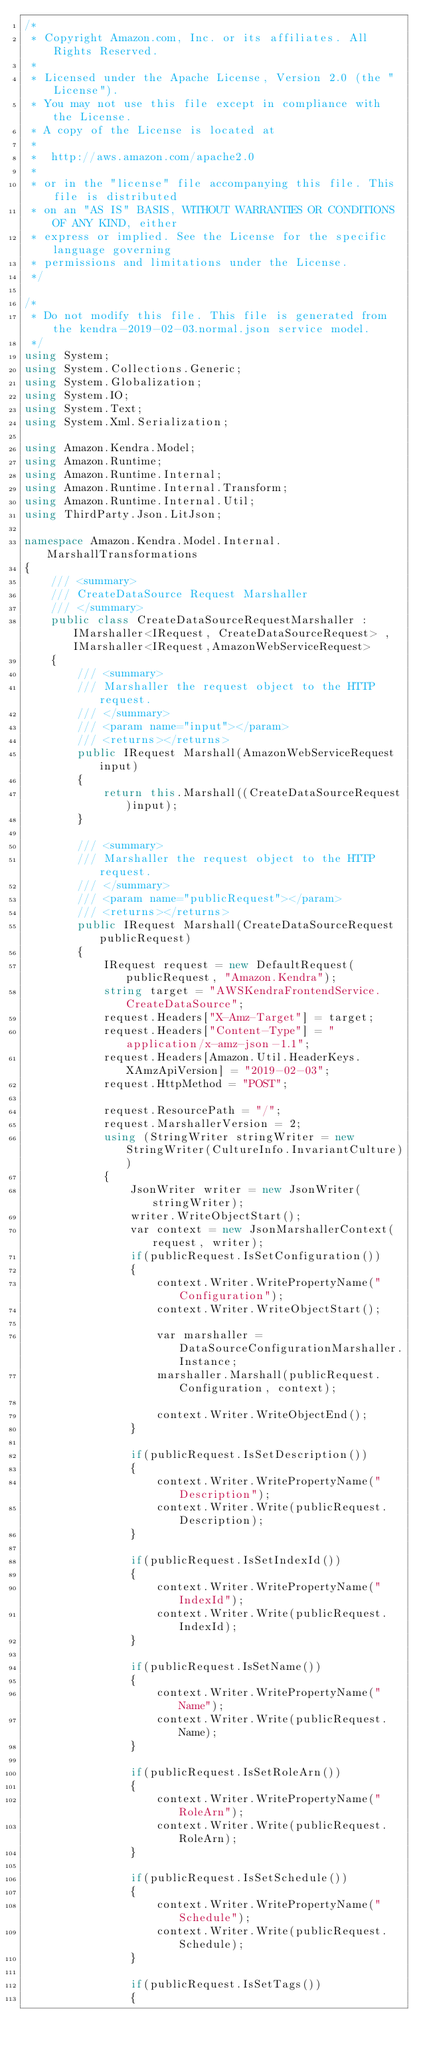Convert code to text. <code><loc_0><loc_0><loc_500><loc_500><_C#_>/*
 * Copyright Amazon.com, Inc. or its affiliates. All Rights Reserved.
 * 
 * Licensed under the Apache License, Version 2.0 (the "License").
 * You may not use this file except in compliance with the License.
 * A copy of the License is located at
 * 
 *  http://aws.amazon.com/apache2.0
 * 
 * or in the "license" file accompanying this file. This file is distributed
 * on an "AS IS" BASIS, WITHOUT WARRANTIES OR CONDITIONS OF ANY KIND, either
 * express or implied. See the License for the specific language governing
 * permissions and limitations under the License.
 */

/*
 * Do not modify this file. This file is generated from the kendra-2019-02-03.normal.json service model.
 */
using System;
using System.Collections.Generic;
using System.Globalization;
using System.IO;
using System.Text;
using System.Xml.Serialization;

using Amazon.Kendra.Model;
using Amazon.Runtime;
using Amazon.Runtime.Internal;
using Amazon.Runtime.Internal.Transform;
using Amazon.Runtime.Internal.Util;
using ThirdParty.Json.LitJson;

namespace Amazon.Kendra.Model.Internal.MarshallTransformations
{
    /// <summary>
    /// CreateDataSource Request Marshaller
    /// </summary>       
    public class CreateDataSourceRequestMarshaller : IMarshaller<IRequest, CreateDataSourceRequest> , IMarshaller<IRequest,AmazonWebServiceRequest>
    {
        /// <summary>
        /// Marshaller the request object to the HTTP request.
        /// </summary>  
        /// <param name="input"></param>
        /// <returns></returns>
        public IRequest Marshall(AmazonWebServiceRequest input)
        {
            return this.Marshall((CreateDataSourceRequest)input);
        }

        /// <summary>
        /// Marshaller the request object to the HTTP request.
        /// </summary>  
        /// <param name="publicRequest"></param>
        /// <returns></returns>
        public IRequest Marshall(CreateDataSourceRequest publicRequest)
        {
            IRequest request = new DefaultRequest(publicRequest, "Amazon.Kendra");
            string target = "AWSKendraFrontendService.CreateDataSource";
            request.Headers["X-Amz-Target"] = target;
            request.Headers["Content-Type"] = "application/x-amz-json-1.1";
            request.Headers[Amazon.Util.HeaderKeys.XAmzApiVersion] = "2019-02-03";            
            request.HttpMethod = "POST";

            request.ResourcePath = "/";
            request.MarshallerVersion = 2;
            using (StringWriter stringWriter = new StringWriter(CultureInfo.InvariantCulture))
            {
                JsonWriter writer = new JsonWriter(stringWriter);
                writer.WriteObjectStart();
                var context = new JsonMarshallerContext(request, writer);
                if(publicRequest.IsSetConfiguration())
                {
                    context.Writer.WritePropertyName("Configuration");
                    context.Writer.WriteObjectStart();

                    var marshaller = DataSourceConfigurationMarshaller.Instance;
                    marshaller.Marshall(publicRequest.Configuration, context);

                    context.Writer.WriteObjectEnd();
                }

                if(publicRequest.IsSetDescription())
                {
                    context.Writer.WritePropertyName("Description");
                    context.Writer.Write(publicRequest.Description);
                }

                if(publicRequest.IsSetIndexId())
                {
                    context.Writer.WritePropertyName("IndexId");
                    context.Writer.Write(publicRequest.IndexId);
                }

                if(publicRequest.IsSetName())
                {
                    context.Writer.WritePropertyName("Name");
                    context.Writer.Write(publicRequest.Name);
                }

                if(publicRequest.IsSetRoleArn())
                {
                    context.Writer.WritePropertyName("RoleArn");
                    context.Writer.Write(publicRequest.RoleArn);
                }

                if(publicRequest.IsSetSchedule())
                {
                    context.Writer.WritePropertyName("Schedule");
                    context.Writer.Write(publicRequest.Schedule);
                }

                if(publicRequest.IsSetTags())
                {</code> 